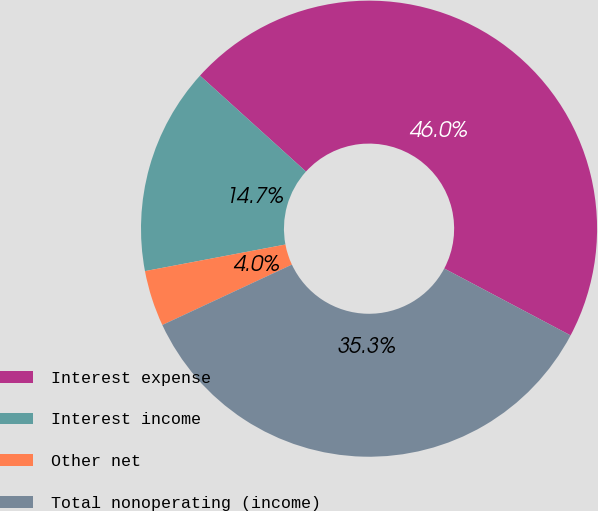Convert chart. <chart><loc_0><loc_0><loc_500><loc_500><pie_chart><fcel>Interest expense<fcel>Interest income<fcel>Other net<fcel>Total nonoperating (income)<nl><fcel>46.04%<fcel>14.69%<fcel>3.96%<fcel>35.31%<nl></chart> 